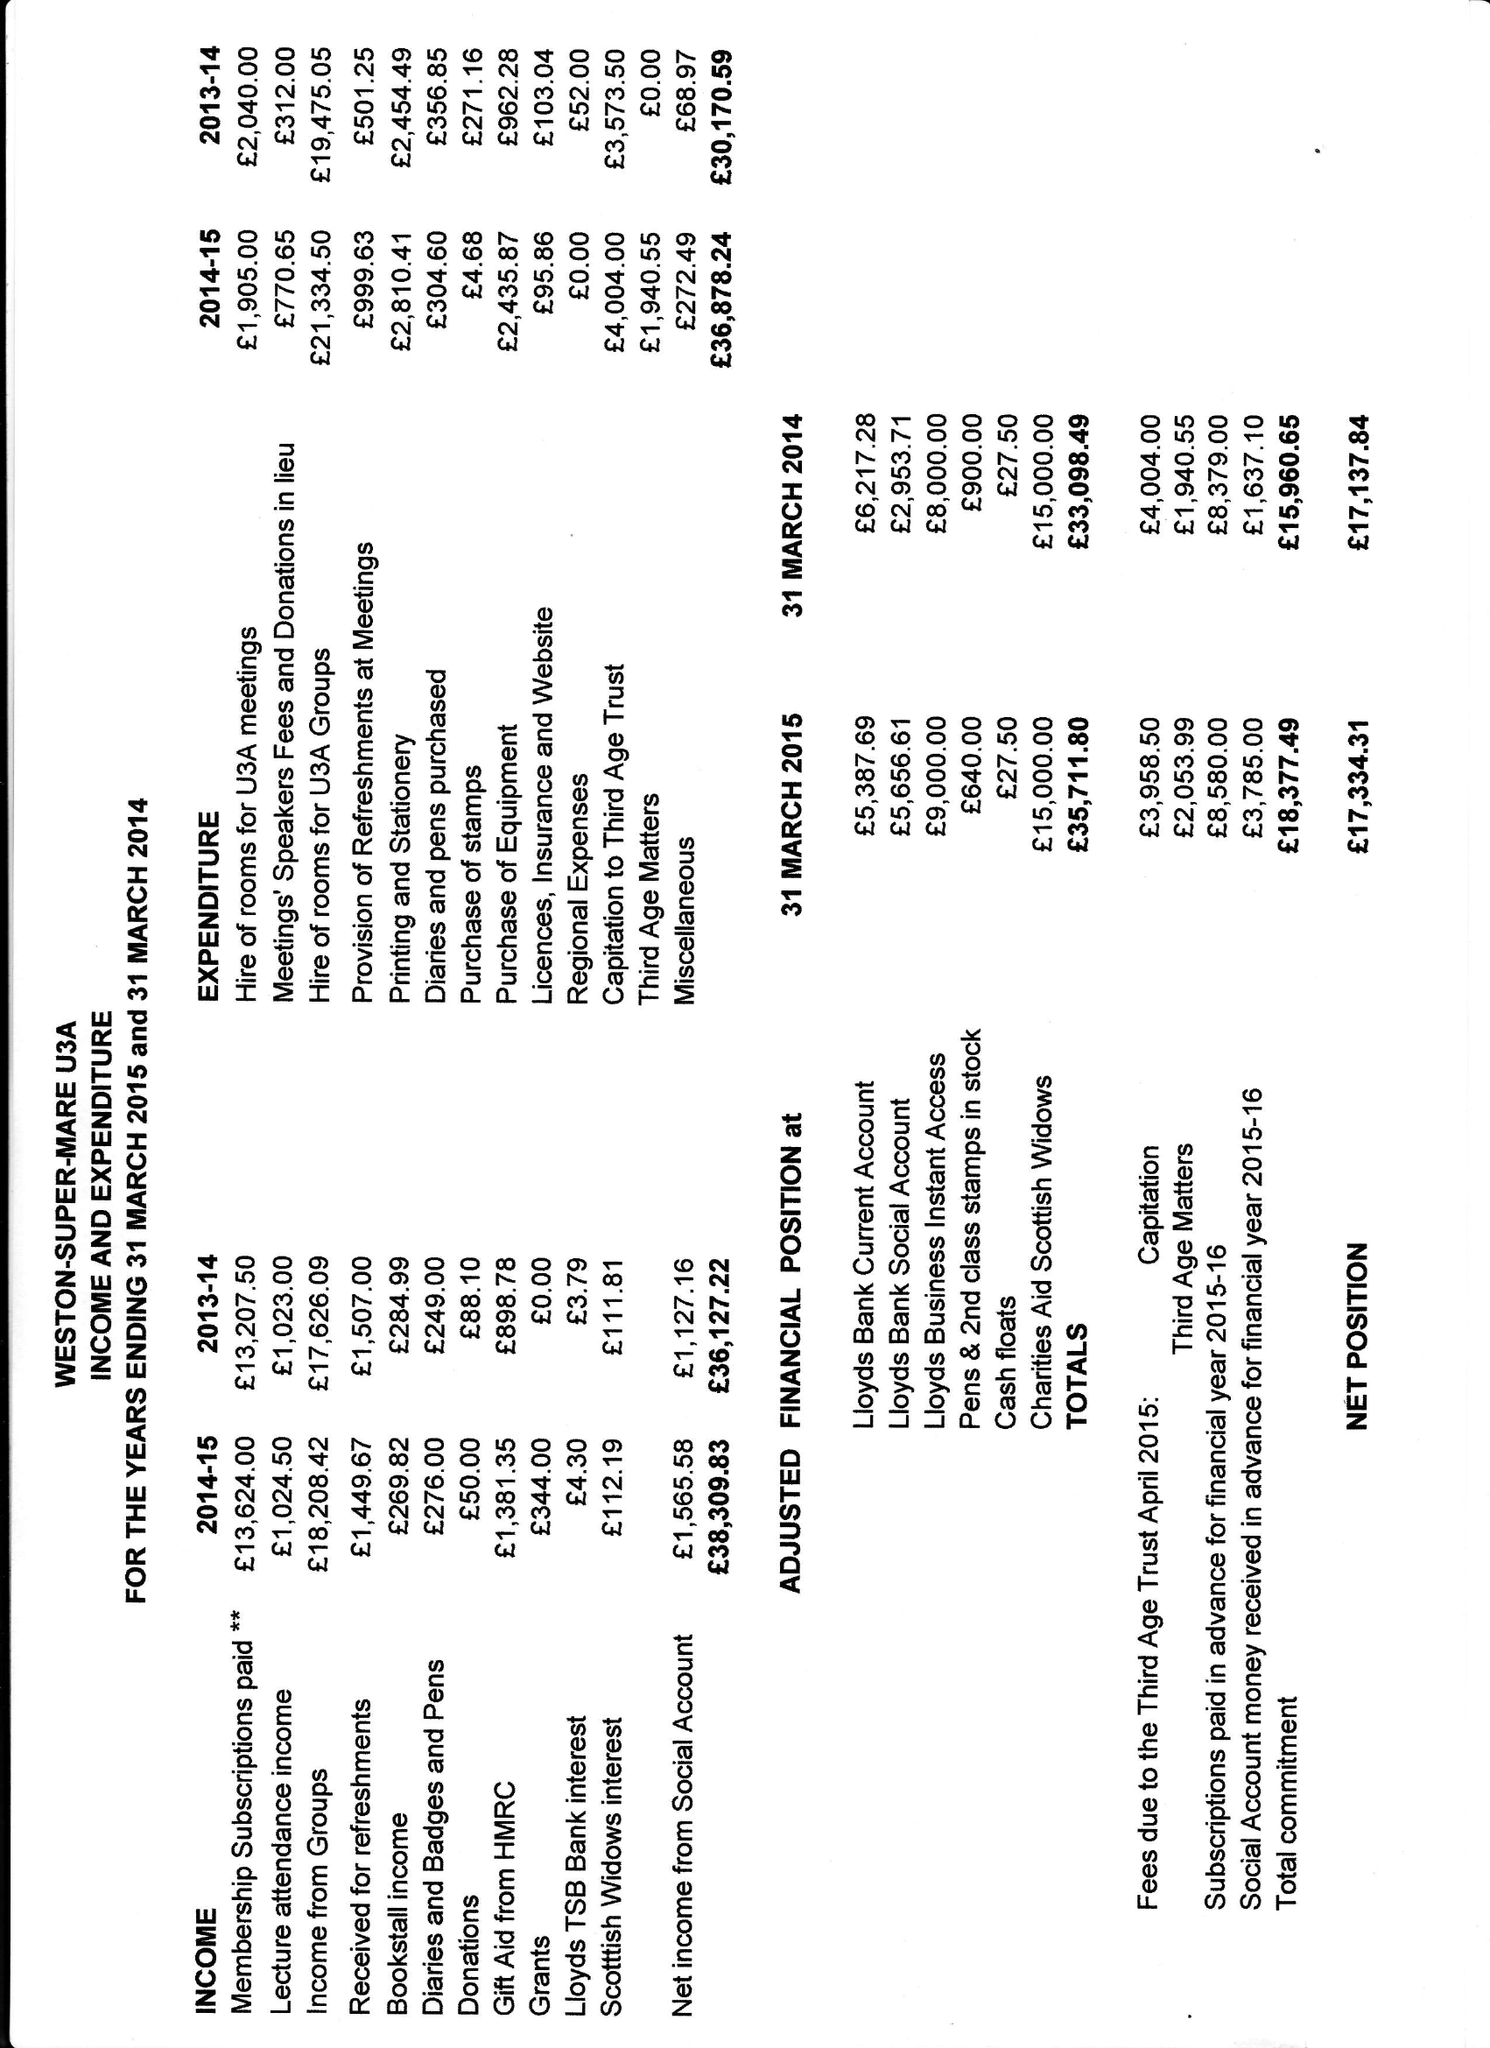What is the value for the income_annually_in_british_pounds?
Answer the question using a single word or phrase. 38309.83 